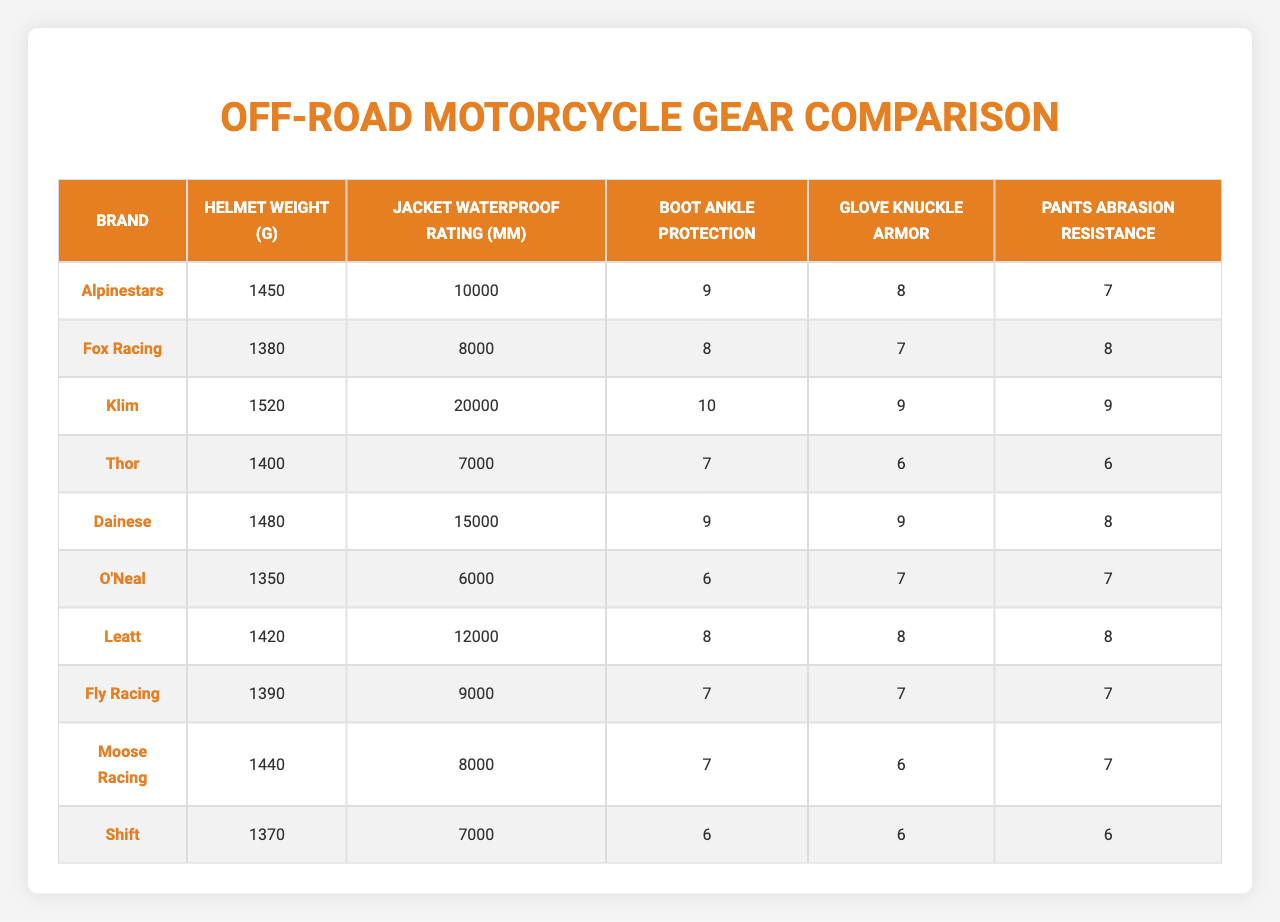What is the helmet weight of Klim? The table shows that Klim has a helmet weight of 1520 grams listed under the "Helmet Weight (g)" column.
Answer: 1520 grams Which brand has the highest jacket waterproof rating? Upon reviewing the jacket waterproof ratings, Klim has the highest rating at 20,000 mm.
Answer: Klim Do Alpinestars gloves have knuckle armor? The table indicates that Alpinestars has a glove knuckle armor rating of 8, which confirms that they do have knuckle armor.
Answer: Yes What is the average helmet weight across all brands? The sum of all helmet weights is 1450 + 1380 + 1520 + 1400 + 1480 + 1350 + 1420 + 1390 + 1440 + 1370 = 14100 grams. Dividing by the total number of brands (10), the average helmet weight is 14100/10 = 1410 grams.
Answer: 1410 grams Which brand has the least ankle protection in boots? When examining the "Boot Ankle Protection" column, O'Neal has the lowest value of 6, indicating it has the least ankle protection.
Answer: O'Neal Is there a brand that has both a higher waterproof rating and ankle protection than Fox Racing? Comparing Fox Racing's waterproof rating (8000 mm) and ankle protection (8), Klim is a brand that meets both conditions, with a waterproof rating of 20000 mm and ankle protection of 10.
Answer: Yes What is the difference in pants abrasion resistance between Dainese and Thor? Dainese's pants abrasion resistance is 8, while Thor's is 6. The difference is calculated by subtracting Thor's value from Dainese's: 8 - 6 = 2.
Answer: 2 Which brand has the best overall protection ratings (jacket, boots, gloves, pants)? To find the brand with the best overall ratings, sum the protection ratings: Klim (10+9+9+9=37), Dainese (9+9+9+8=35), Alpinestars (9+8+8+7=32), and others. Klim has the highest total with 37.
Answer: Klim What percentage of brands provide knuckle armor of 8 or more? There are 10 brands in total, and 5 brands (Klim, Dainese, Leatt, Alpinestars) have a knuckle armor rating of 8 or more. The percentage is (5/10) * 100 = 50%.
Answer: 50% Does Fly Racing have the same waterproof rating as Moose Racing? Reviewing the table, Fly Racing has a waterproof rating of 9000 mm while Moose Racing has 8000 mm. Therefore, they do not have the same waterproof rating.
Answer: No 